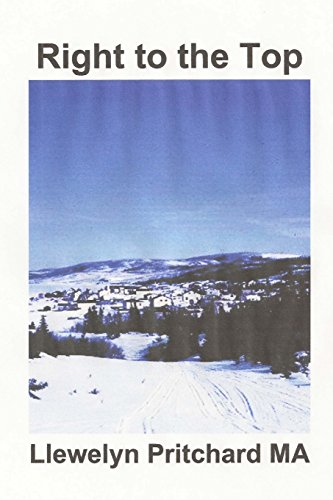Who is the author of this book?
Answer the question using a single word or phrase. Llewelyn Pritchard MA What is the title of this book? Right to the Top: "Wrigglesworth corrupt group proceed with caution" (Port Hope Simpson Mysteries) (Volume 7) (Vietnamese Edition) What type of book is this? Teen & Young Adult Is this book related to Teen & Young Adult? Yes Is this book related to Humor & Entertainment? No 